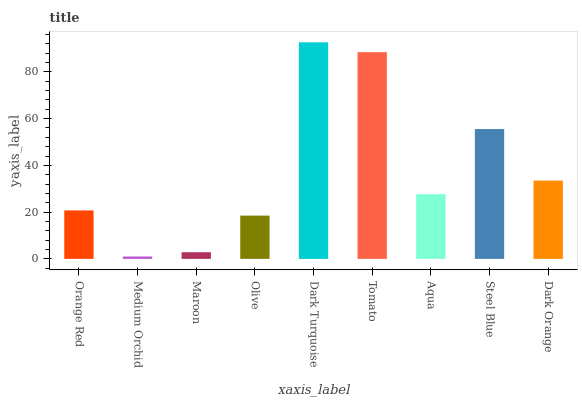Is Medium Orchid the minimum?
Answer yes or no. Yes. Is Dark Turquoise the maximum?
Answer yes or no. Yes. Is Maroon the minimum?
Answer yes or no. No. Is Maroon the maximum?
Answer yes or no. No. Is Maroon greater than Medium Orchid?
Answer yes or no. Yes. Is Medium Orchid less than Maroon?
Answer yes or no. Yes. Is Medium Orchid greater than Maroon?
Answer yes or no. No. Is Maroon less than Medium Orchid?
Answer yes or no. No. Is Aqua the high median?
Answer yes or no. Yes. Is Aqua the low median?
Answer yes or no. Yes. Is Dark Turquoise the high median?
Answer yes or no. No. Is Orange Red the low median?
Answer yes or no. No. 